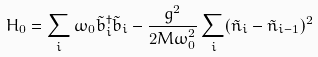Convert formula to latex. <formula><loc_0><loc_0><loc_500><loc_500>H _ { 0 } = \sum _ { i } \omega _ { 0 } \tilde { b } ^ { \dagger } _ { i } \tilde { b } _ { i } - \frac { g ^ { 2 } } { 2 M \omega _ { 0 } ^ { 2 } } \sum _ { i } ( \tilde { n } _ { i } - \tilde { n } _ { i - 1 } ) ^ { 2 }</formula> 